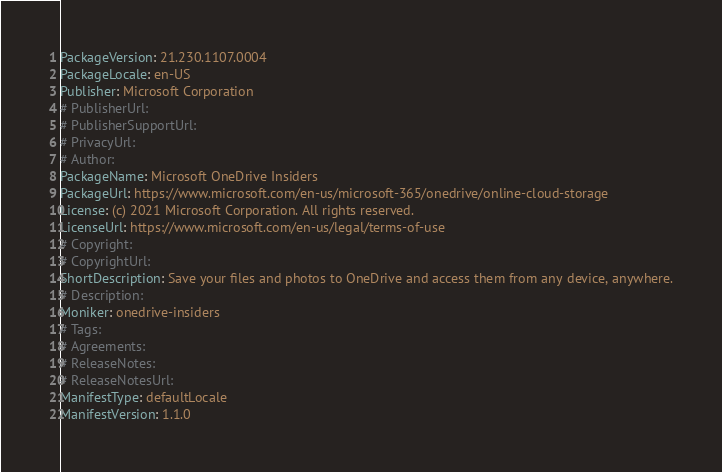Convert code to text. <code><loc_0><loc_0><loc_500><loc_500><_YAML_>PackageVersion: 21.230.1107.0004
PackageLocale: en-US
Publisher: Microsoft Corporation
# PublisherUrl: 
# PublisherSupportUrl: 
# PrivacyUrl: 
# Author: 
PackageName: Microsoft OneDrive Insiders
PackageUrl: https://www.microsoft.com/en-us/microsoft-365/onedrive/online-cloud-storage
License: (c) 2021 Microsoft Corporation. All rights reserved.
LicenseUrl: https://www.microsoft.com/en-us/legal/terms-of-use
# Copyright: 
# CopyrightUrl: 
ShortDescription: Save your files and photos to OneDrive and access them from any device, anywhere.
# Description: 
Moniker: onedrive-insiders
# Tags: 
# Agreements: 
# ReleaseNotes: 
# ReleaseNotesUrl: 
ManifestType: defaultLocale
ManifestVersion: 1.1.0
</code> 